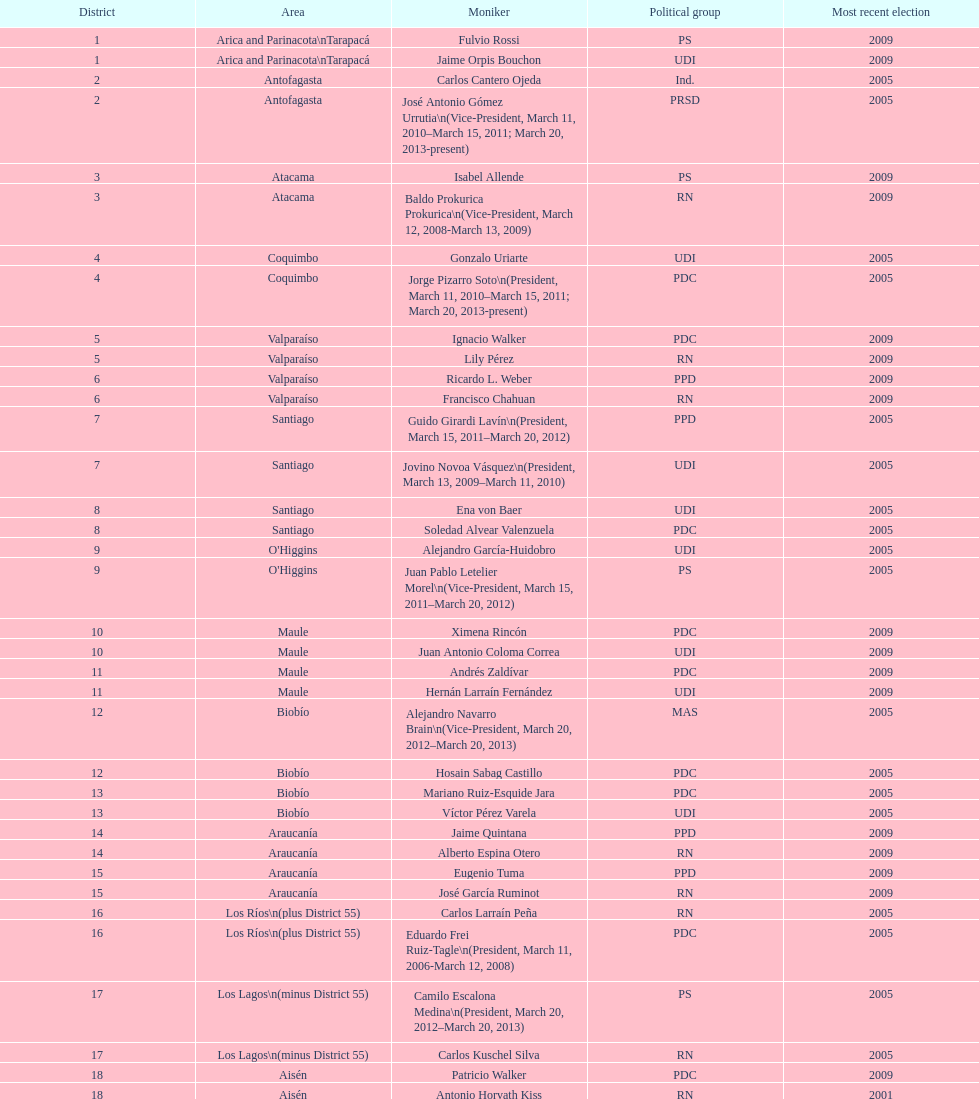What is the total number of constituencies? 19. 